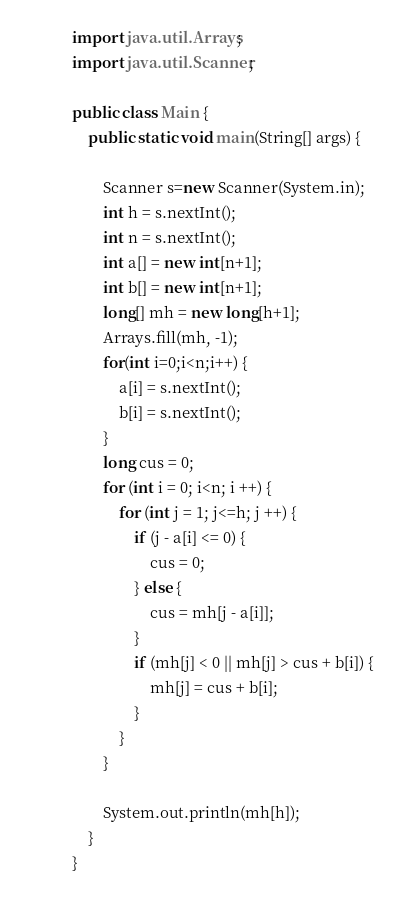Convert code to text. <code><loc_0><loc_0><loc_500><loc_500><_Java_>import java.util.Arrays;
import java.util.Scanner;

public class Main {
    public static void main(String[] args) {

        Scanner s=new Scanner(System.in);
        int h = s.nextInt();
        int n = s.nextInt();
        int a[] = new int[n+1];
        int b[] = new int[n+1];
        long[] mh = new long[h+1];
        Arrays.fill(mh, -1);
        for(int i=0;i<n;i++) {
            a[i] = s.nextInt();
            b[i] = s.nextInt();
        }
        long cus = 0;
        for (int i = 0; i<n; i ++) {
            for (int j = 1; j<=h; j ++) {
                if (j - a[i] <= 0) {
                    cus = 0;
                } else {
                    cus = mh[j - a[i]];
                }
                if (mh[j] < 0 || mh[j] > cus + b[i]) {
                    mh[j] = cus + b[i];
                }
            }
        }

        System.out.println(mh[h]);
    }
}</code> 